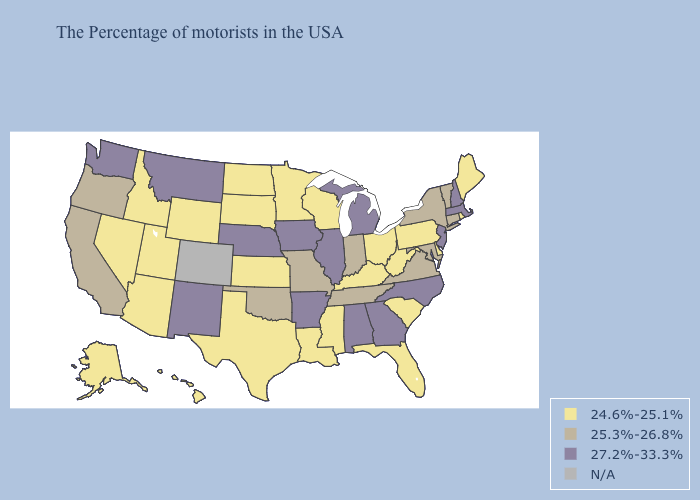What is the lowest value in the South?
Write a very short answer. 24.6%-25.1%. What is the value of West Virginia?
Give a very brief answer. 24.6%-25.1%. Does North Carolina have the lowest value in the USA?
Short answer required. No. Does Louisiana have the lowest value in the USA?
Answer briefly. Yes. What is the value of Vermont?
Give a very brief answer. 25.3%-26.8%. What is the value of Maryland?
Short answer required. 25.3%-26.8%. Name the states that have a value in the range 27.2%-33.3%?
Be succinct. Massachusetts, New Hampshire, New Jersey, North Carolina, Georgia, Michigan, Alabama, Illinois, Arkansas, Iowa, Nebraska, New Mexico, Montana, Washington. What is the lowest value in the USA?
Keep it brief. 24.6%-25.1%. What is the lowest value in the USA?
Concise answer only. 24.6%-25.1%. What is the value of Vermont?
Answer briefly. 25.3%-26.8%. Name the states that have a value in the range 27.2%-33.3%?
Answer briefly. Massachusetts, New Hampshire, New Jersey, North Carolina, Georgia, Michigan, Alabama, Illinois, Arkansas, Iowa, Nebraska, New Mexico, Montana, Washington. What is the value of Michigan?
Answer briefly. 27.2%-33.3%. What is the value of Mississippi?
Quick response, please. 24.6%-25.1%. What is the highest value in the USA?
Be succinct. 27.2%-33.3%. 